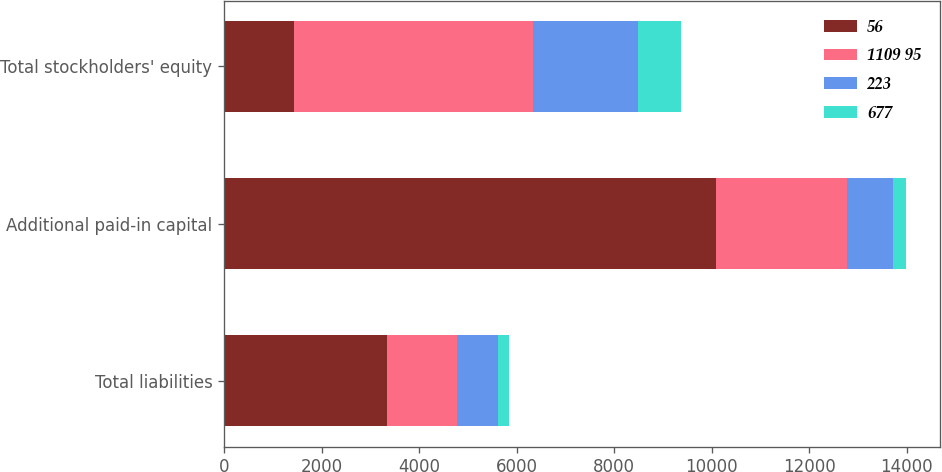Convert chart to OTSL. <chart><loc_0><loc_0><loc_500><loc_500><stacked_bar_chart><ecel><fcel>Total liabilities<fcel>Additional paid-in capital<fcel>Total stockholders' equity<nl><fcel>56<fcel>3348<fcel>10094<fcel>1432<nl><fcel>1109 95<fcel>1432<fcel>2684<fcel>4899<nl><fcel>223<fcel>828<fcel>947<fcel>2162<nl><fcel>677<fcel>241<fcel>253<fcel>868<nl></chart> 